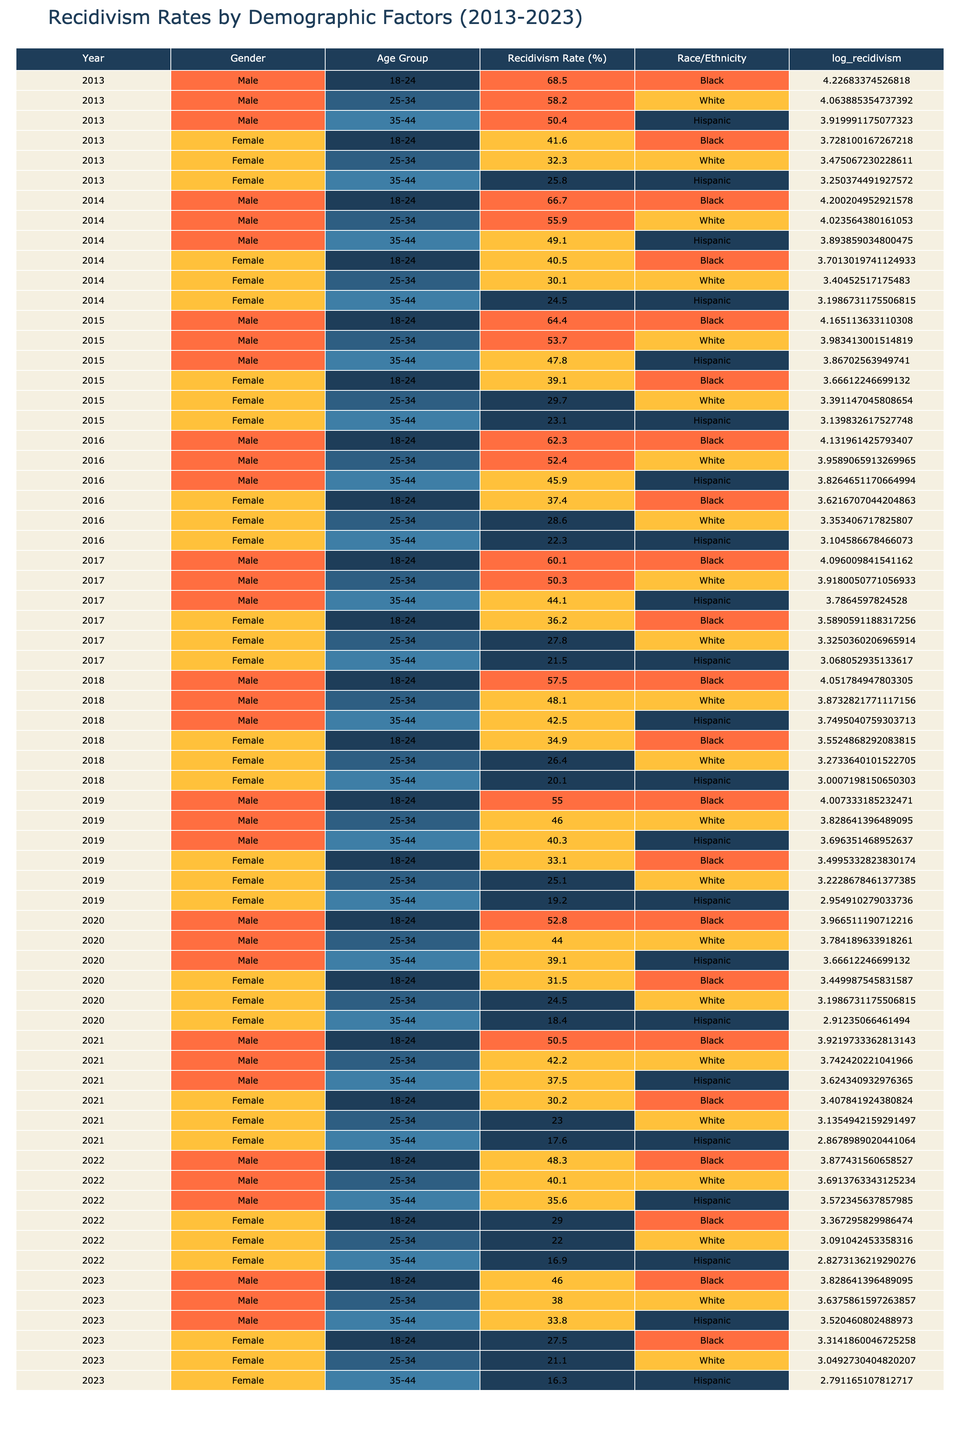What was the recidivism rate for Black males aged 18-24 in 2013? Referring to the table, the recidivism rate for Black males aged 18-24 in 2013 is listed directly in the corresponding cell as 68.5%.
Answer: 68.5% What is the average recidivism rate for Hispanic females across all years? To find the average, we sum the recidivism rates for Hispanic females: 25.8 + 24.5 + 23.1 + 22.3 + 21.5 + 20.1 + 19.2 + 18.4 + 17.6 + 16.9 + 16.3 =  246.7. There are 11 values, therefore the average is 246.7 / 11 ≈ 22.52%.
Answer: 22.52% Is the recidivism rate for male prisoners aged 25-34 always higher than that for female prisoners aged 25-34? By comparing the recidivism rates side by side from the table, we see that for every year listed, the male recidivism rates for this age group are consistently higher than those of females. Therefore, the answer is yes.
Answer: Yes Which demographic showed the greatest decrease in recidivism rate from 2013 to 2023 among females? Looking at the table, we find the recidivism rates for females across the years: 41.6 (2013) to 27.5 (2023) for Black females, which is a decrease of 14.1%. The values for White and Hispanic females also decrease but not as significantly as Black females.
Answer: Black females What is the difference in the recidivism rate for males aged 35-44 between 2013 and 2023? The recidivism rate for male prisoners aged 35-44 in 2013 is 50.4%, and in 2023 it is 33.8%. To find the difference, we subtract these two values: 50.4 - 33.8 = 16.6%.
Answer: 16.6% Was the recidivism rate for White males aged 25-34 higher in 2015 than for the same demographic in 2020? From the table, we see that in 2015 the rate is 53.7% while in 2020 it is 44%. Thus, comparing these figures indicates that the rate in 2015 was indeed higher than in 2020.
Answer: Yes What trend can be observed in the recidivism rates for Black males aged 18-24 from 2013 to 2023? Analyzing the rates, we have 68.5% in 2013, decreasing to 46.0% in 2023. This indicates a consistent downward trend over the decade.
Answer: Decreasing trend Which race/ethnicity of females showed the lowest recidivism rate in 2023? Looking at the table, we find that in 2023, the recidivism rates for Black, White, and Hispanic females are 27.5%, 21.1%, and 16.3%, respectively. The Hispanic demographic represents the lowest value at 16.3%.
Answer: Hispanic females 